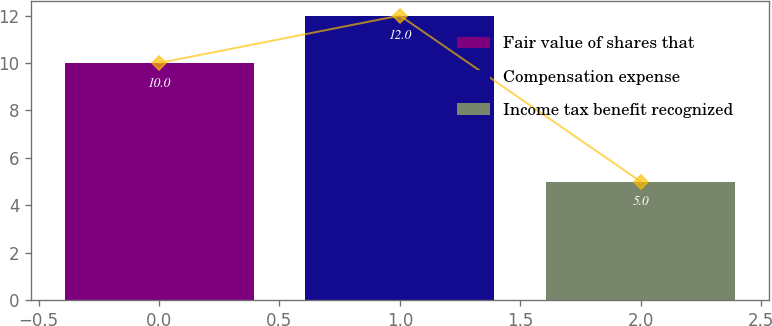Convert chart to OTSL. <chart><loc_0><loc_0><loc_500><loc_500><bar_chart><fcel>Fair value of shares that<fcel>Compensation expense<fcel>Income tax benefit recognized<nl><fcel>10<fcel>12<fcel>5<nl></chart> 